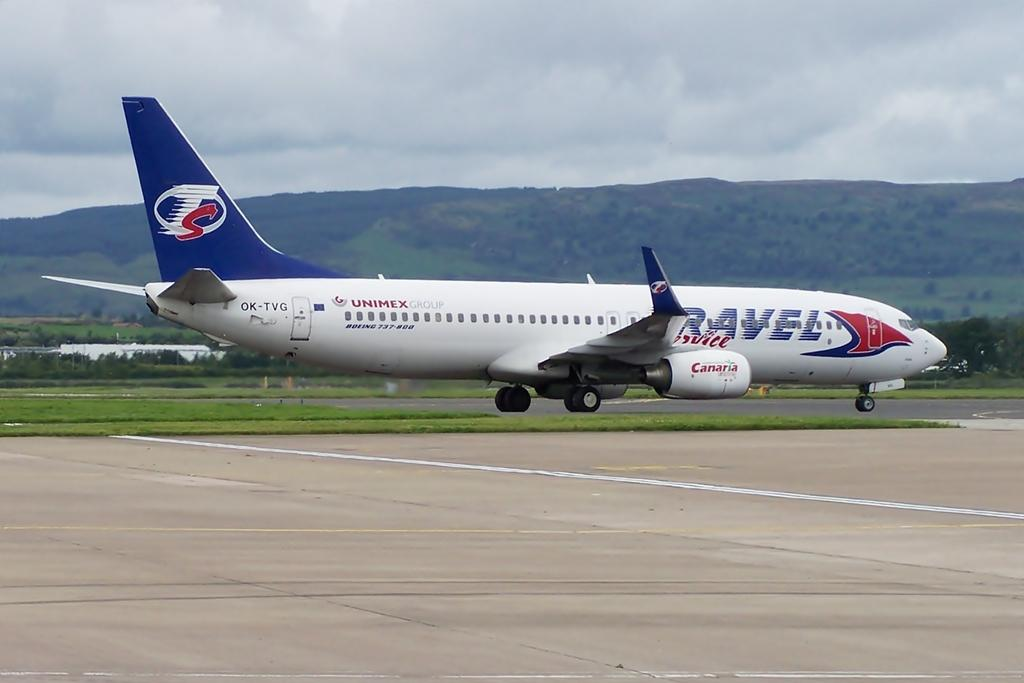What is the main subject of the image? The main subject of the image is a plane. What colors can be seen on the plane? The plane is white and blue in color. Where is the plane located in the image? The plane is on a runway. What can be seen in the background of the image? There are trees and mountains in the background of the image. What type of poison is being used by the company in the image? There is no mention of poison or a company in the image; it features a plane on a runway with trees and mountains in the background. 